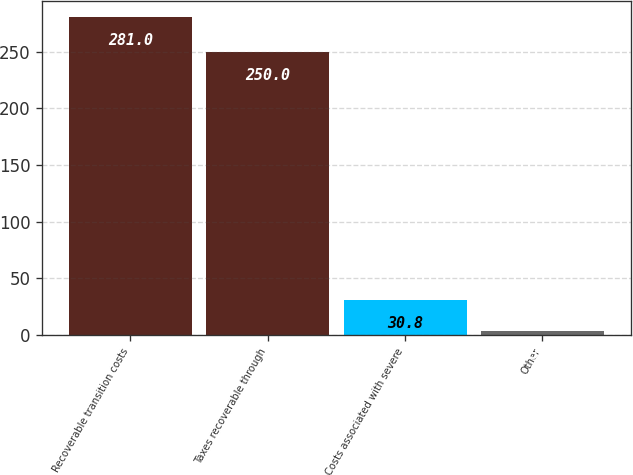Convert chart to OTSL. <chart><loc_0><loc_0><loc_500><loc_500><bar_chart><fcel>Recoverable transition costs<fcel>Taxes recoverable through<fcel>Costs associated with severe<fcel>Other<nl><fcel>281<fcel>250<fcel>30.8<fcel>3<nl></chart> 